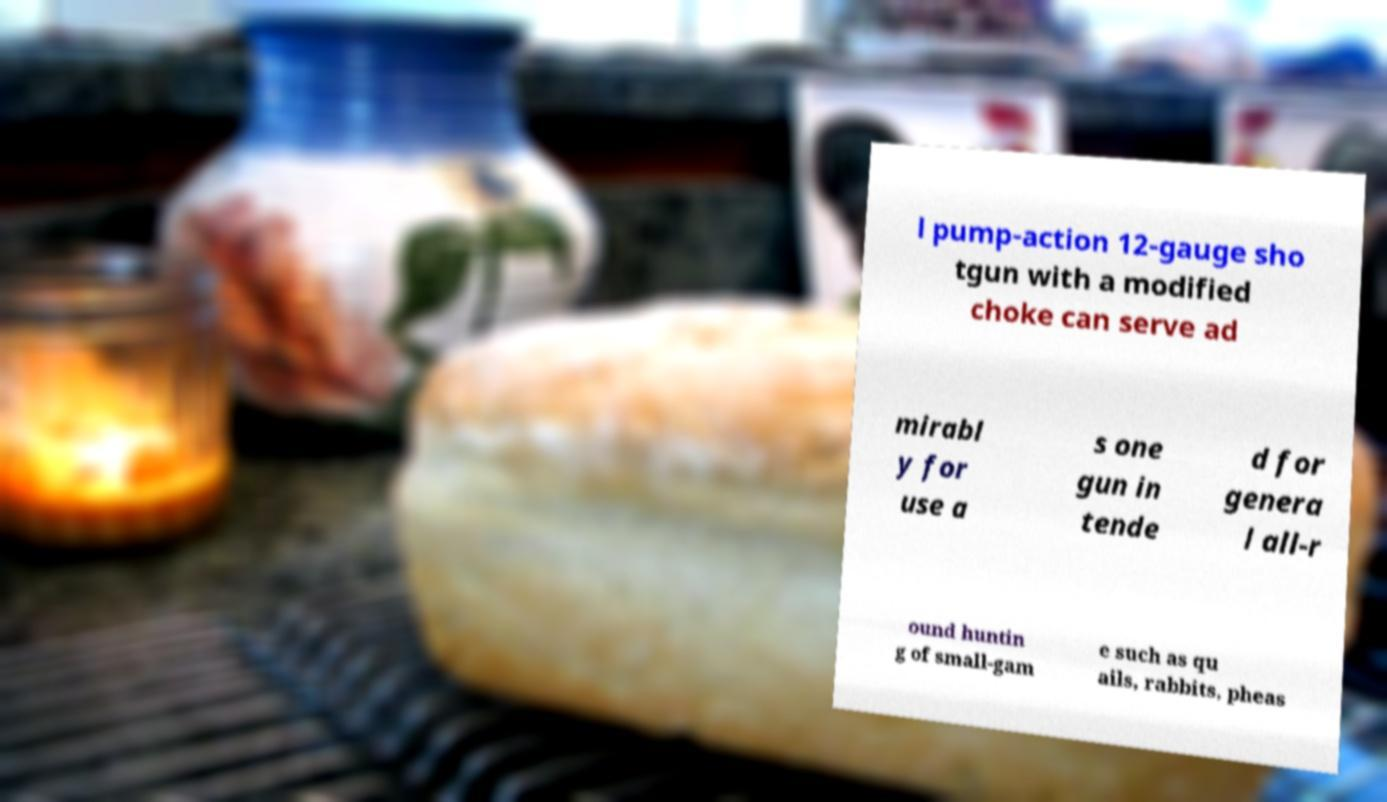There's text embedded in this image that I need extracted. Can you transcribe it verbatim? l pump-action 12-gauge sho tgun with a modified choke can serve ad mirabl y for use a s one gun in tende d for genera l all-r ound huntin g of small-gam e such as qu ails, rabbits, pheas 